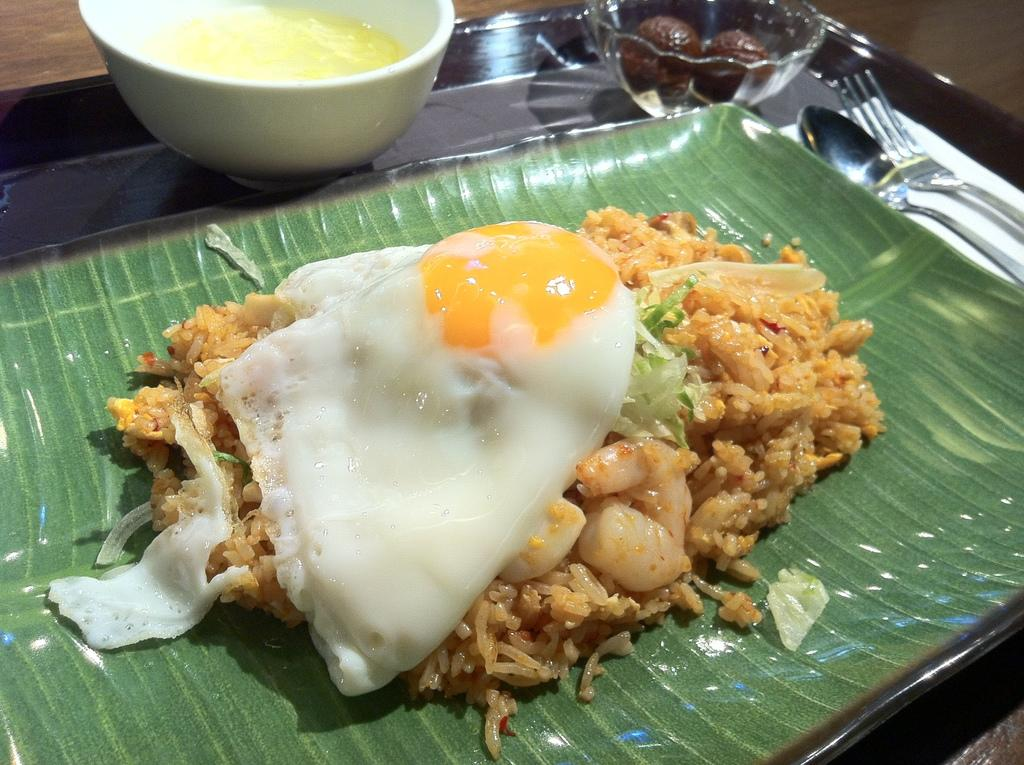What type of food can be seen in the image? There is food in a plate in the image. How many bowls are visible in the image? There are bowls in the image. What utensils are present in the image? There is a spoon and a fork in the image. Where are all these items located? All these items are on a table. What creature is responsible for organizing the event in the image? There is no creature or event present in the image; it only shows food, bowls, a spoon, a fork, and a table. 